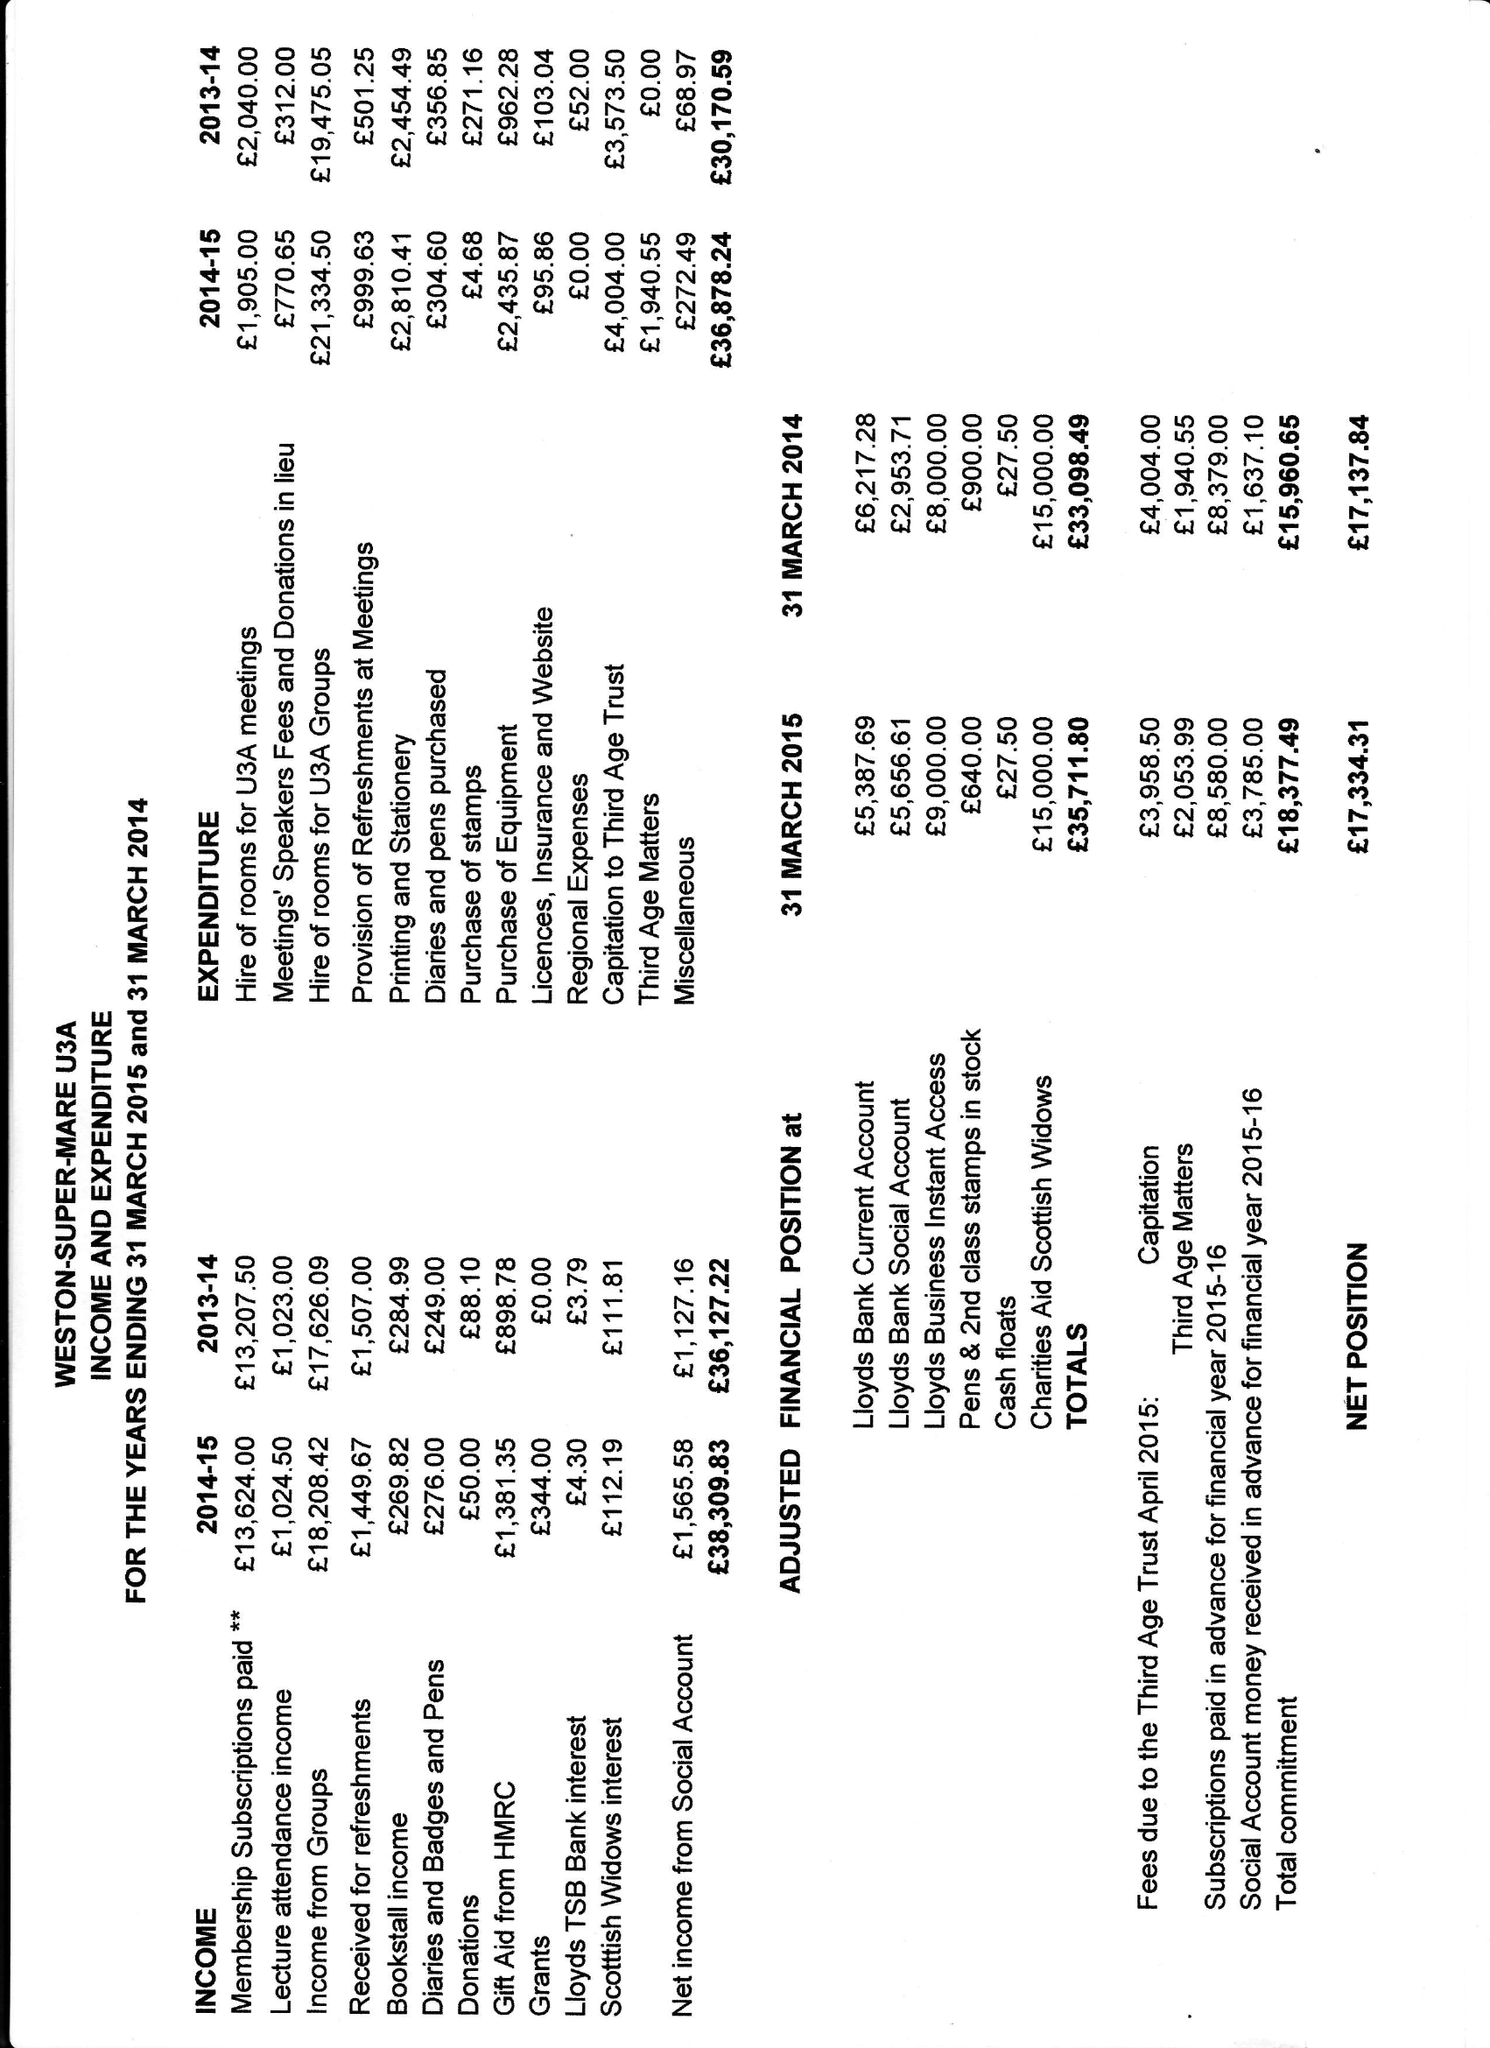What is the value for the spending_annually_in_british_pounds?
Answer the question using a single word or phrase. 36878.24 